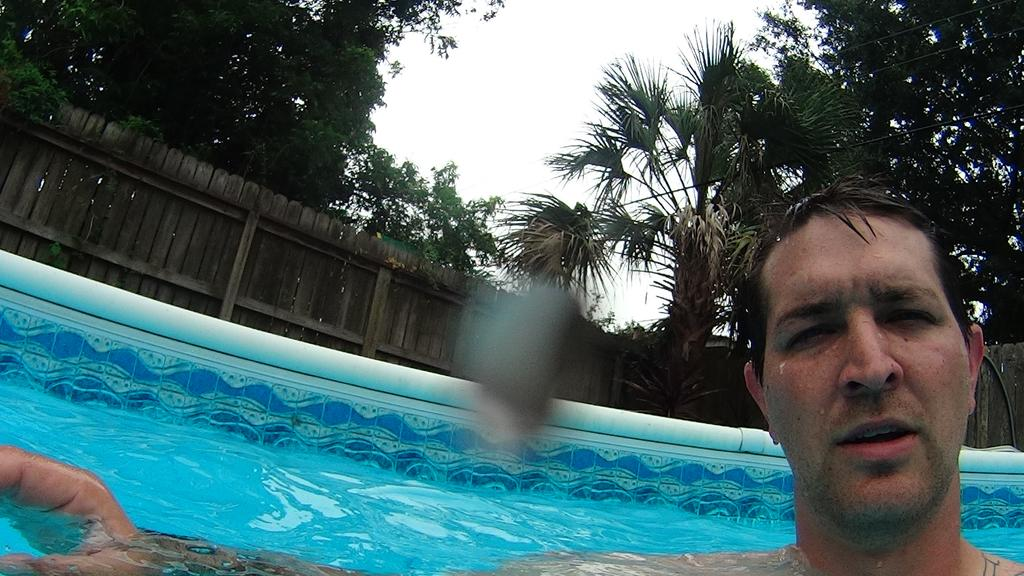What is the person in the image doing? There is a person standing in the swimming pool. What can be seen in the background of the image? There is a wooden fence wall and trees visible in the background. What type of education does the person in the image have? There is no information about the person's education in the image. 